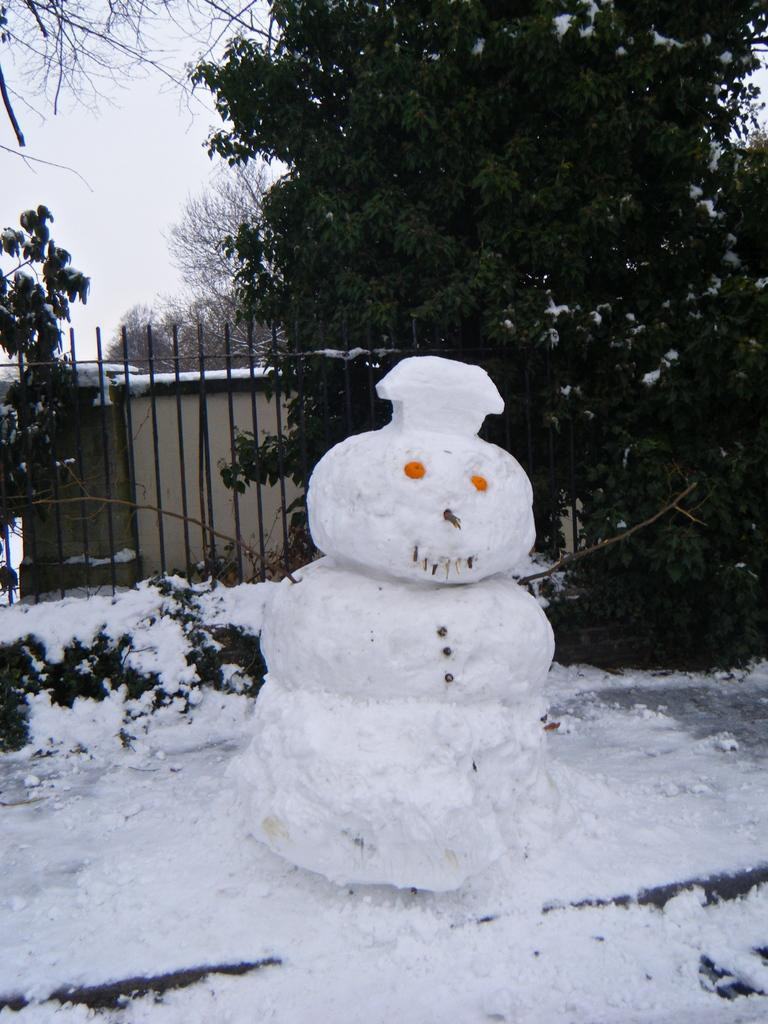What is the main object in the center of the image? There is a snow toy in the center of the image. What can be seen in the background of the image? There are trees in the background of the image. What type of weather is suggested by the presence of snow in the image? The presence of snow suggests cold weather. Can you see a pickle hanging from the tree in the image? There is no pickle present in the image; it features a snow toy and trees in the background. 